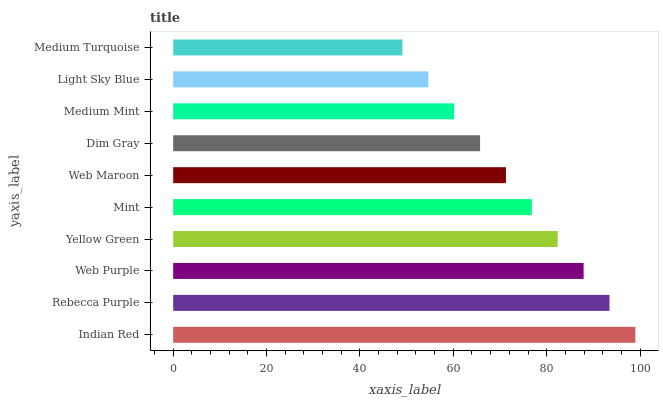Is Medium Turquoise the minimum?
Answer yes or no. Yes. Is Indian Red the maximum?
Answer yes or no. Yes. Is Rebecca Purple the minimum?
Answer yes or no. No. Is Rebecca Purple the maximum?
Answer yes or no. No. Is Indian Red greater than Rebecca Purple?
Answer yes or no. Yes. Is Rebecca Purple less than Indian Red?
Answer yes or no. Yes. Is Rebecca Purple greater than Indian Red?
Answer yes or no. No. Is Indian Red less than Rebecca Purple?
Answer yes or no. No. Is Mint the high median?
Answer yes or no. Yes. Is Web Maroon the low median?
Answer yes or no. Yes. Is Yellow Green the high median?
Answer yes or no. No. Is Rebecca Purple the low median?
Answer yes or no. No. 